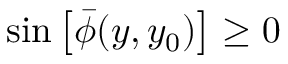<formula> <loc_0><loc_0><loc_500><loc_500>\sin \left [ \bar { \phi } ( y , y _ { 0 } ) \right ] \geq 0</formula> 